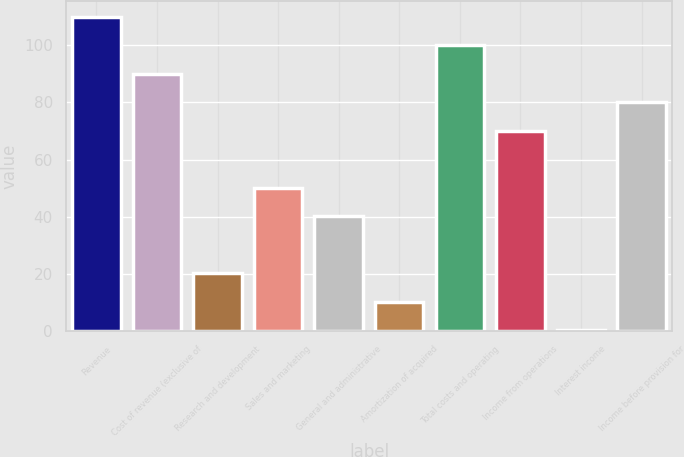<chart> <loc_0><loc_0><loc_500><loc_500><bar_chart><fcel>Revenue<fcel>Cost of revenue (exclusive of<fcel>Research and development<fcel>Sales and marketing<fcel>General and administrative<fcel>Amortization of acquired<fcel>Total costs and operating<fcel>Income from operations<fcel>Interest income<fcel>Income before provision for<nl><fcel>109.96<fcel>90.04<fcel>20.32<fcel>50.2<fcel>40.24<fcel>10.36<fcel>100<fcel>70.12<fcel>0.4<fcel>80.08<nl></chart> 